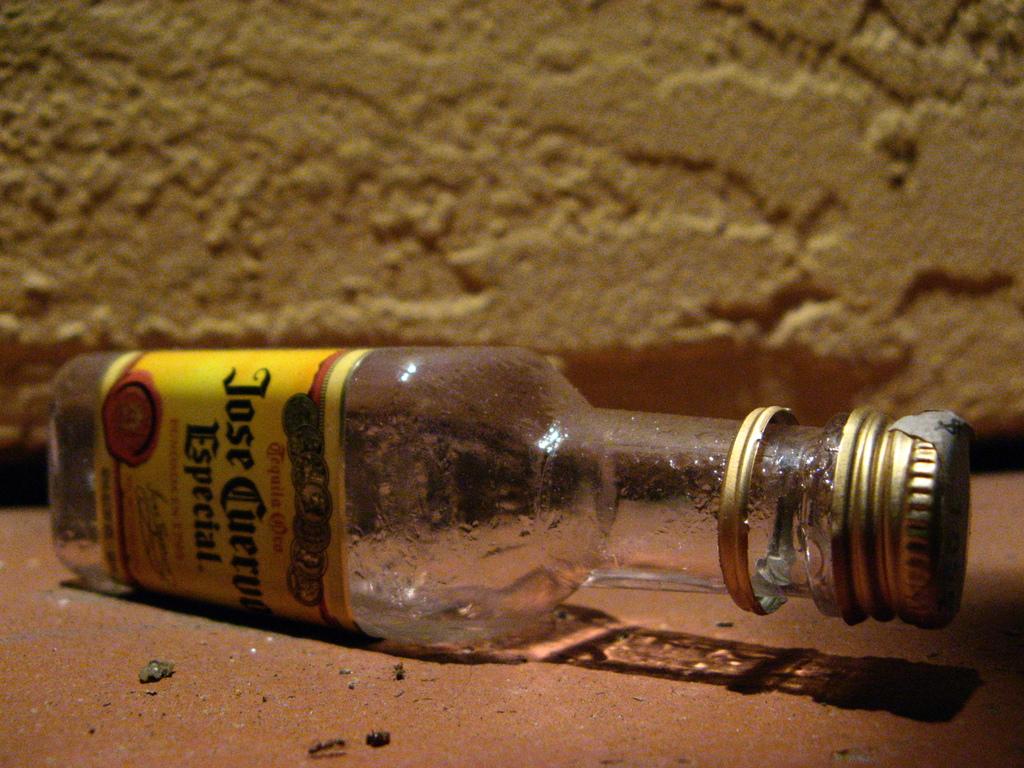What is the brand of tequila shown on this bottle?
Offer a very short reply. Jose cuervo. 